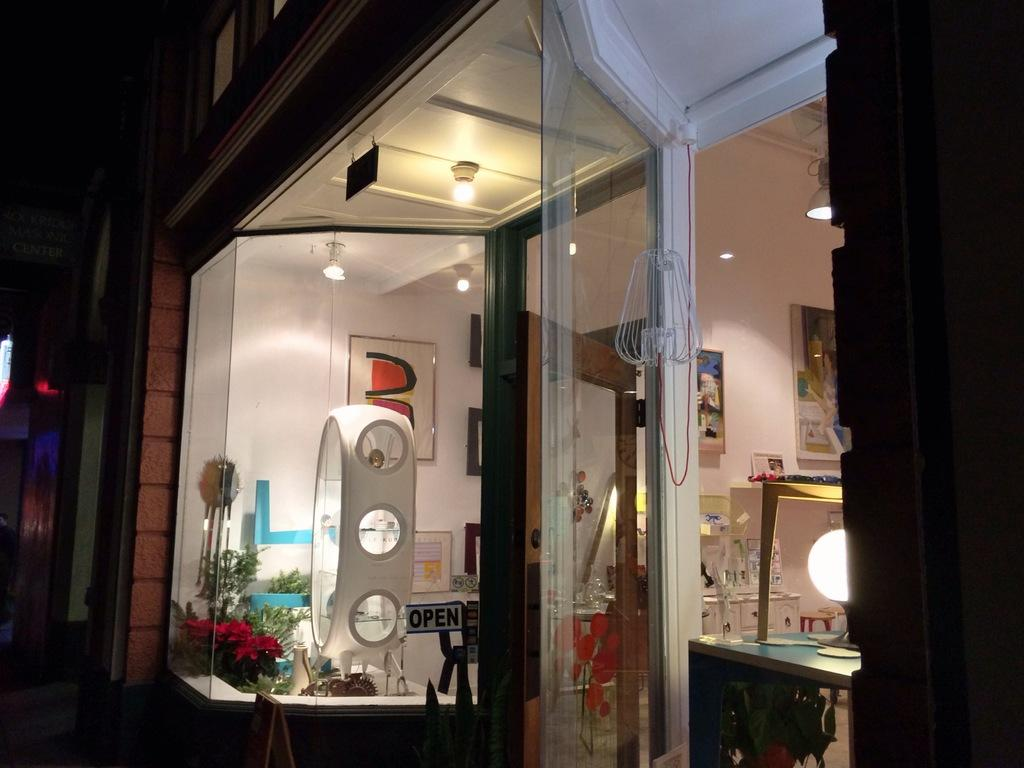What type of wall is present in the image? There is a framed glass wall in the image. What other feature related to the wall can be seen? There is a glass door in the image. What is attached to the glass wall? Photo frames are attached to the wall in the image. What type of lighting is present in the image? There are lights on the ceiling in the image. How would you describe the overall lighting in the image? The background of the image is dark. How many teeth can be seen in the image? There are no teeth visible in the image. What type of clam is present in the image? There are no clams present in the image. 